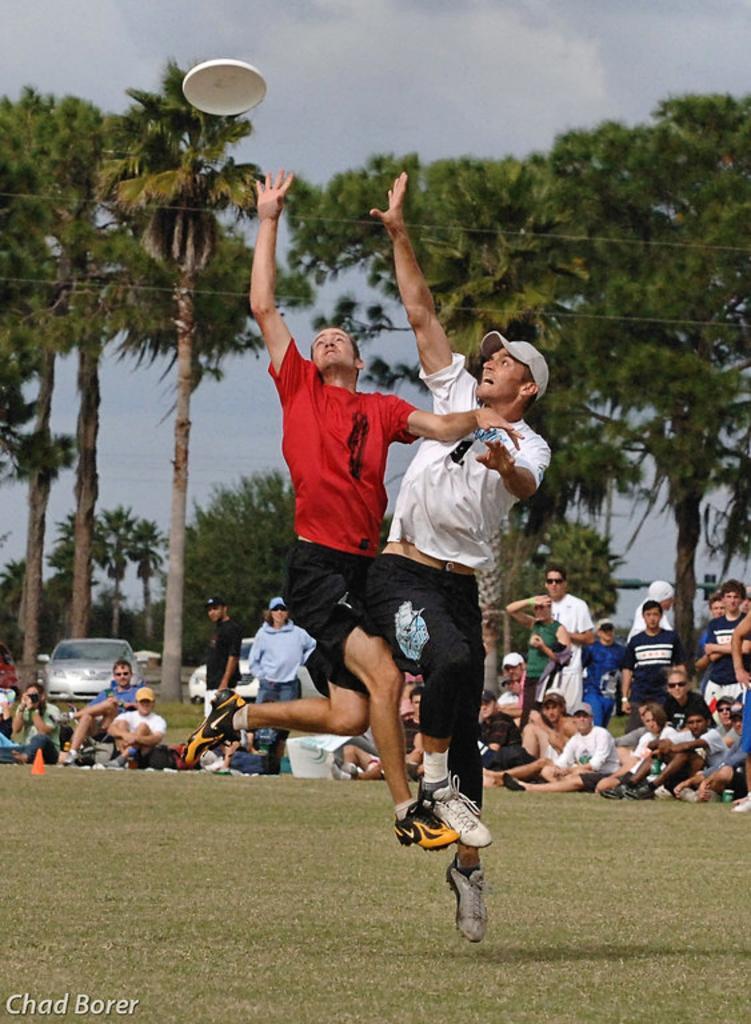Can you describe this image briefly? In the center of the image we can see two people are jumping and trying to catch an object. In the background of the image we can see the trees, car, a group of people, grass. At the bottom of the image we can see the ground. At the top of the image we can see the clouds are present in the sky. In the bottom left corner we can see the text. On the left side of the image we can see a divider cone. 